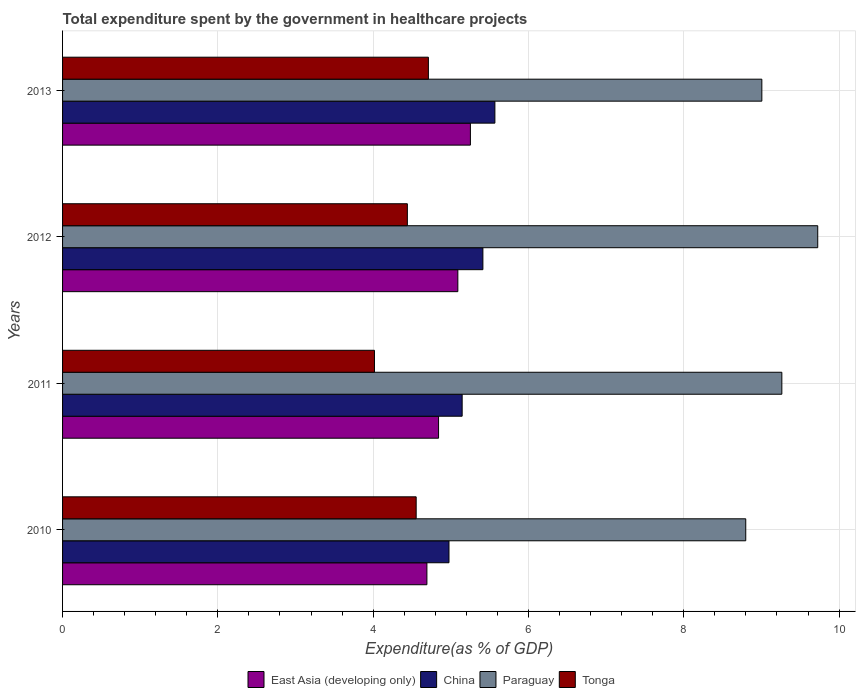How many groups of bars are there?
Offer a very short reply. 4. How many bars are there on the 4th tick from the bottom?
Make the answer very short. 4. What is the label of the 4th group of bars from the top?
Provide a succinct answer. 2010. In how many cases, is the number of bars for a given year not equal to the number of legend labels?
Provide a short and direct response. 0. What is the total expenditure spent by the government in healthcare projects in East Asia (developing only) in 2013?
Your answer should be very brief. 5.25. Across all years, what is the maximum total expenditure spent by the government in healthcare projects in Paraguay?
Your response must be concise. 9.73. Across all years, what is the minimum total expenditure spent by the government in healthcare projects in East Asia (developing only)?
Your answer should be compact. 4.69. In which year was the total expenditure spent by the government in healthcare projects in East Asia (developing only) minimum?
Offer a terse response. 2010. What is the total total expenditure spent by the government in healthcare projects in China in the graph?
Give a very brief answer. 21.1. What is the difference between the total expenditure spent by the government in healthcare projects in East Asia (developing only) in 2010 and that in 2012?
Your response must be concise. -0.4. What is the difference between the total expenditure spent by the government in healthcare projects in East Asia (developing only) in 2010 and the total expenditure spent by the government in healthcare projects in China in 2013?
Provide a succinct answer. -0.88. What is the average total expenditure spent by the government in healthcare projects in China per year?
Keep it short and to the point. 5.28. In the year 2012, what is the difference between the total expenditure spent by the government in healthcare projects in Tonga and total expenditure spent by the government in healthcare projects in East Asia (developing only)?
Provide a short and direct response. -0.65. What is the ratio of the total expenditure spent by the government in healthcare projects in Tonga in 2010 to that in 2013?
Offer a very short reply. 0.97. What is the difference between the highest and the second highest total expenditure spent by the government in healthcare projects in Paraguay?
Keep it short and to the point. 0.46. What is the difference between the highest and the lowest total expenditure spent by the government in healthcare projects in Tonga?
Give a very brief answer. 0.69. In how many years, is the total expenditure spent by the government in healthcare projects in China greater than the average total expenditure spent by the government in healthcare projects in China taken over all years?
Your answer should be compact. 2. Is the sum of the total expenditure spent by the government in healthcare projects in Tonga in 2011 and 2012 greater than the maximum total expenditure spent by the government in healthcare projects in China across all years?
Provide a succinct answer. Yes. Is it the case that in every year, the sum of the total expenditure spent by the government in healthcare projects in China and total expenditure spent by the government in healthcare projects in Paraguay is greater than the sum of total expenditure spent by the government in healthcare projects in Tonga and total expenditure spent by the government in healthcare projects in East Asia (developing only)?
Your answer should be compact. Yes. What does the 4th bar from the bottom in 2012 represents?
Give a very brief answer. Tonga. How many bars are there?
Provide a short and direct response. 16. Does the graph contain any zero values?
Your answer should be very brief. No. How many legend labels are there?
Offer a terse response. 4. What is the title of the graph?
Ensure brevity in your answer.  Total expenditure spent by the government in healthcare projects. What is the label or title of the X-axis?
Provide a succinct answer. Expenditure(as % of GDP). What is the Expenditure(as % of GDP) of East Asia (developing only) in 2010?
Your response must be concise. 4.69. What is the Expenditure(as % of GDP) in China in 2010?
Offer a terse response. 4.98. What is the Expenditure(as % of GDP) in Paraguay in 2010?
Your answer should be compact. 8.8. What is the Expenditure(as % of GDP) in Tonga in 2010?
Keep it short and to the point. 4.55. What is the Expenditure(as % of GDP) of East Asia (developing only) in 2011?
Offer a very short reply. 4.84. What is the Expenditure(as % of GDP) of China in 2011?
Your answer should be very brief. 5.15. What is the Expenditure(as % of GDP) of Paraguay in 2011?
Keep it short and to the point. 9.26. What is the Expenditure(as % of GDP) in Tonga in 2011?
Offer a very short reply. 4.02. What is the Expenditure(as % of GDP) of East Asia (developing only) in 2012?
Your response must be concise. 5.09. What is the Expenditure(as % of GDP) in China in 2012?
Provide a succinct answer. 5.41. What is the Expenditure(as % of GDP) in Paraguay in 2012?
Give a very brief answer. 9.73. What is the Expenditure(as % of GDP) of Tonga in 2012?
Give a very brief answer. 4.44. What is the Expenditure(as % of GDP) in East Asia (developing only) in 2013?
Your answer should be compact. 5.25. What is the Expenditure(as % of GDP) in China in 2013?
Your answer should be very brief. 5.57. What is the Expenditure(as % of GDP) of Paraguay in 2013?
Offer a very short reply. 9.01. What is the Expenditure(as % of GDP) of Tonga in 2013?
Offer a very short reply. 4.71. Across all years, what is the maximum Expenditure(as % of GDP) in East Asia (developing only)?
Provide a succinct answer. 5.25. Across all years, what is the maximum Expenditure(as % of GDP) in China?
Offer a very short reply. 5.57. Across all years, what is the maximum Expenditure(as % of GDP) in Paraguay?
Offer a terse response. 9.73. Across all years, what is the maximum Expenditure(as % of GDP) in Tonga?
Provide a short and direct response. 4.71. Across all years, what is the minimum Expenditure(as % of GDP) in East Asia (developing only)?
Provide a succinct answer. 4.69. Across all years, what is the minimum Expenditure(as % of GDP) of China?
Offer a very short reply. 4.98. Across all years, what is the minimum Expenditure(as % of GDP) of Paraguay?
Offer a very short reply. 8.8. Across all years, what is the minimum Expenditure(as % of GDP) of Tonga?
Keep it short and to the point. 4.02. What is the total Expenditure(as % of GDP) in East Asia (developing only) in the graph?
Provide a succinct answer. 19.88. What is the total Expenditure(as % of GDP) of China in the graph?
Keep it short and to the point. 21.1. What is the total Expenditure(as % of GDP) of Paraguay in the graph?
Give a very brief answer. 36.79. What is the total Expenditure(as % of GDP) in Tonga in the graph?
Make the answer very short. 17.72. What is the difference between the Expenditure(as % of GDP) in East Asia (developing only) in 2010 and that in 2011?
Your answer should be compact. -0.15. What is the difference between the Expenditure(as % of GDP) in China in 2010 and that in 2011?
Offer a terse response. -0.17. What is the difference between the Expenditure(as % of GDP) in Paraguay in 2010 and that in 2011?
Your answer should be very brief. -0.46. What is the difference between the Expenditure(as % of GDP) in Tonga in 2010 and that in 2011?
Provide a succinct answer. 0.54. What is the difference between the Expenditure(as % of GDP) in East Asia (developing only) in 2010 and that in 2012?
Ensure brevity in your answer.  -0.4. What is the difference between the Expenditure(as % of GDP) in China in 2010 and that in 2012?
Offer a terse response. -0.44. What is the difference between the Expenditure(as % of GDP) in Paraguay in 2010 and that in 2012?
Your response must be concise. -0.93. What is the difference between the Expenditure(as % of GDP) of Tonga in 2010 and that in 2012?
Keep it short and to the point. 0.11. What is the difference between the Expenditure(as % of GDP) of East Asia (developing only) in 2010 and that in 2013?
Provide a succinct answer. -0.56. What is the difference between the Expenditure(as % of GDP) of China in 2010 and that in 2013?
Make the answer very short. -0.59. What is the difference between the Expenditure(as % of GDP) of Paraguay in 2010 and that in 2013?
Provide a succinct answer. -0.21. What is the difference between the Expenditure(as % of GDP) in Tonga in 2010 and that in 2013?
Offer a terse response. -0.16. What is the difference between the Expenditure(as % of GDP) in East Asia (developing only) in 2011 and that in 2012?
Offer a terse response. -0.25. What is the difference between the Expenditure(as % of GDP) in China in 2011 and that in 2012?
Provide a short and direct response. -0.27. What is the difference between the Expenditure(as % of GDP) of Paraguay in 2011 and that in 2012?
Keep it short and to the point. -0.46. What is the difference between the Expenditure(as % of GDP) of Tonga in 2011 and that in 2012?
Provide a short and direct response. -0.42. What is the difference between the Expenditure(as % of GDP) in East Asia (developing only) in 2011 and that in 2013?
Ensure brevity in your answer.  -0.41. What is the difference between the Expenditure(as % of GDP) of China in 2011 and that in 2013?
Make the answer very short. -0.42. What is the difference between the Expenditure(as % of GDP) in Paraguay in 2011 and that in 2013?
Make the answer very short. 0.26. What is the difference between the Expenditure(as % of GDP) of Tonga in 2011 and that in 2013?
Make the answer very short. -0.69. What is the difference between the Expenditure(as % of GDP) in East Asia (developing only) in 2012 and that in 2013?
Your response must be concise. -0.16. What is the difference between the Expenditure(as % of GDP) of China in 2012 and that in 2013?
Keep it short and to the point. -0.15. What is the difference between the Expenditure(as % of GDP) in Paraguay in 2012 and that in 2013?
Provide a succinct answer. 0.72. What is the difference between the Expenditure(as % of GDP) of Tonga in 2012 and that in 2013?
Provide a succinct answer. -0.27. What is the difference between the Expenditure(as % of GDP) in East Asia (developing only) in 2010 and the Expenditure(as % of GDP) in China in 2011?
Give a very brief answer. -0.45. What is the difference between the Expenditure(as % of GDP) of East Asia (developing only) in 2010 and the Expenditure(as % of GDP) of Paraguay in 2011?
Your response must be concise. -4.57. What is the difference between the Expenditure(as % of GDP) in East Asia (developing only) in 2010 and the Expenditure(as % of GDP) in Tonga in 2011?
Your answer should be compact. 0.68. What is the difference between the Expenditure(as % of GDP) in China in 2010 and the Expenditure(as % of GDP) in Paraguay in 2011?
Give a very brief answer. -4.29. What is the difference between the Expenditure(as % of GDP) of China in 2010 and the Expenditure(as % of GDP) of Tonga in 2011?
Offer a terse response. 0.96. What is the difference between the Expenditure(as % of GDP) in Paraguay in 2010 and the Expenditure(as % of GDP) in Tonga in 2011?
Provide a short and direct response. 4.78. What is the difference between the Expenditure(as % of GDP) of East Asia (developing only) in 2010 and the Expenditure(as % of GDP) of China in 2012?
Provide a short and direct response. -0.72. What is the difference between the Expenditure(as % of GDP) in East Asia (developing only) in 2010 and the Expenditure(as % of GDP) in Paraguay in 2012?
Keep it short and to the point. -5.03. What is the difference between the Expenditure(as % of GDP) in East Asia (developing only) in 2010 and the Expenditure(as % of GDP) in Tonga in 2012?
Give a very brief answer. 0.25. What is the difference between the Expenditure(as % of GDP) in China in 2010 and the Expenditure(as % of GDP) in Paraguay in 2012?
Your answer should be very brief. -4.75. What is the difference between the Expenditure(as % of GDP) of China in 2010 and the Expenditure(as % of GDP) of Tonga in 2012?
Make the answer very short. 0.54. What is the difference between the Expenditure(as % of GDP) of Paraguay in 2010 and the Expenditure(as % of GDP) of Tonga in 2012?
Keep it short and to the point. 4.36. What is the difference between the Expenditure(as % of GDP) of East Asia (developing only) in 2010 and the Expenditure(as % of GDP) of China in 2013?
Provide a succinct answer. -0.88. What is the difference between the Expenditure(as % of GDP) of East Asia (developing only) in 2010 and the Expenditure(as % of GDP) of Paraguay in 2013?
Provide a succinct answer. -4.31. What is the difference between the Expenditure(as % of GDP) of East Asia (developing only) in 2010 and the Expenditure(as % of GDP) of Tonga in 2013?
Keep it short and to the point. -0.02. What is the difference between the Expenditure(as % of GDP) in China in 2010 and the Expenditure(as % of GDP) in Paraguay in 2013?
Your response must be concise. -4.03. What is the difference between the Expenditure(as % of GDP) in China in 2010 and the Expenditure(as % of GDP) in Tonga in 2013?
Provide a short and direct response. 0.27. What is the difference between the Expenditure(as % of GDP) in Paraguay in 2010 and the Expenditure(as % of GDP) in Tonga in 2013?
Provide a succinct answer. 4.09. What is the difference between the Expenditure(as % of GDP) in East Asia (developing only) in 2011 and the Expenditure(as % of GDP) in China in 2012?
Your response must be concise. -0.57. What is the difference between the Expenditure(as % of GDP) in East Asia (developing only) in 2011 and the Expenditure(as % of GDP) in Paraguay in 2012?
Your response must be concise. -4.88. What is the difference between the Expenditure(as % of GDP) in East Asia (developing only) in 2011 and the Expenditure(as % of GDP) in Tonga in 2012?
Keep it short and to the point. 0.4. What is the difference between the Expenditure(as % of GDP) of China in 2011 and the Expenditure(as % of GDP) of Paraguay in 2012?
Ensure brevity in your answer.  -4.58. What is the difference between the Expenditure(as % of GDP) in China in 2011 and the Expenditure(as % of GDP) in Tonga in 2012?
Offer a terse response. 0.71. What is the difference between the Expenditure(as % of GDP) in Paraguay in 2011 and the Expenditure(as % of GDP) in Tonga in 2012?
Offer a terse response. 4.82. What is the difference between the Expenditure(as % of GDP) of East Asia (developing only) in 2011 and the Expenditure(as % of GDP) of China in 2013?
Ensure brevity in your answer.  -0.73. What is the difference between the Expenditure(as % of GDP) in East Asia (developing only) in 2011 and the Expenditure(as % of GDP) in Paraguay in 2013?
Give a very brief answer. -4.16. What is the difference between the Expenditure(as % of GDP) of East Asia (developing only) in 2011 and the Expenditure(as % of GDP) of Tonga in 2013?
Your response must be concise. 0.13. What is the difference between the Expenditure(as % of GDP) of China in 2011 and the Expenditure(as % of GDP) of Paraguay in 2013?
Offer a terse response. -3.86. What is the difference between the Expenditure(as % of GDP) of China in 2011 and the Expenditure(as % of GDP) of Tonga in 2013?
Keep it short and to the point. 0.43. What is the difference between the Expenditure(as % of GDP) in Paraguay in 2011 and the Expenditure(as % of GDP) in Tonga in 2013?
Offer a very short reply. 4.55. What is the difference between the Expenditure(as % of GDP) of East Asia (developing only) in 2012 and the Expenditure(as % of GDP) of China in 2013?
Your answer should be very brief. -0.48. What is the difference between the Expenditure(as % of GDP) in East Asia (developing only) in 2012 and the Expenditure(as % of GDP) in Paraguay in 2013?
Provide a succinct answer. -3.91. What is the difference between the Expenditure(as % of GDP) of East Asia (developing only) in 2012 and the Expenditure(as % of GDP) of Tonga in 2013?
Keep it short and to the point. 0.38. What is the difference between the Expenditure(as % of GDP) of China in 2012 and the Expenditure(as % of GDP) of Paraguay in 2013?
Make the answer very short. -3.59. What is the difference between the Expenditure(as % of GDP) in China in 2012 and the Expenditure(as % of GDP) in Tonga in 2013?
Your answer should be compact. 0.7. What is the difference between the Expenditure(as % of GDP) of Paraguay in 2012 and the Expenditure(as % of GDP) of Tonga in 2013?
Your response must be concise. 5.01. What is the average Expenditure(as % of GDP) of East Asia (developing only) per year?
Offer a very short reply. 4.97. What is the average Expenditure(as % of GDP) in China per year?
Provide a succinct answer. 5.28. What is the average Expenditure(as % of GDP) in Paraguay per year?
Your response must be concise. 9.2. What is the average Expenditure(as % of GDP) of Tonga per year?
Your response must be concise. 4.43. In the year 2010, what is the difference between the Expenditure(as % of GDP) in East Asia (developing only) and Expenditure(as % of GDP) in China?
Your answer should be compact. -0.28. In the year 2010, what is the difference between the Expenditure(as % of GDP) in East Asia (developing only) and Expenditure(as % of GDP) in Paraguay?
Provide a succinct answer. -4.11. In the year 2010, what is the difference between the Expenditure(as % of GDP) of East Asia (developing only) and Expenditure(as % of GDP) of Tonga?
Offer a terse response. 0.14. In the year 2010, what is the difference between the Expenditure(as % of GDP) in China and Expenditure(as % of GDP) in Paraguay?
Provide a succinct answer. -3.82. In the year 2010, what is the difference between the Expenditure(as % of GDP) in China and Expenditure(as % of GDP) in Tonga?
Give a very brief answer. 0.42. In the year 2010, what is the difference between the Expenditure(as % of GDP) in Paraguay and Expenditure(as % of GDP) in Tonga?
Offer a very short reply. 4.24. In the year 2011, what is the difference between the Expenditure(as % of GDP) in East Asia (developing only) and Expenditure(as % of GDP) in China?
Give a very brief answer. -0.3. In the year 2011, what is the difference between the Expenditure(as % of GDP) of East Asia (developing only) and Expenditure(as % of GDP) of Paraguay?
Offer a very short reply. -4.42. In the year 2011, what is the difference between the Expenditure(as % of GDP) of East Asia (developing only) and Expenditure(as % of GDP) of Tonga?
Your answer should be compact. 0.83. In the year 2011, what is the difference between the Expenditure(as % of GDP) in China and Expenditure(as % of GDP) in Paraguay?
Offer a terse response. -4.12. In the year 2011, what is the difference between the Expenditure(as % of GDP) in China and Expenditure(as % of GDP) in Tonga?
Your answer should be very brief. 1.13. In the year 2011, what is the difference between the Expenditure(as % of GDP) of Paraguay and Expenditure(as % of GDP) of Tonga?
Keep it short and to the point. 5.25. In the year 2012, what is the difference between the Expenditure(as % of GDP) of East Asia (developing only) and Expenditure(as % of GDP) of China?
Keep it short and to the point. -0.32. In the year 2012, what is the difference between the Expenditure(as % of GDP) in East Asia (developing only) and Expenditure(as % of GDP) in Paraguay?
Ensure brevity in your answer.  -4.63. In the year 2012, what is the difference between the Expenditure(as % of GDP) in East Asia (developing only) and Expenditure(as % of GDP) in Tonga?
Offer a terse response. 0.65. In the year 2012, what is the difference between the Expenditure(as % of GDP) of China and Expenditure(as % of GDP) of Paraguay?
Give a very brief answer. -4.31. In the year 2012, what is the difference between the Expenditure(as % of GDP) in China and Expenditure(as % of GDP) in Tonga?
Your answer should be compact. 0.97. In the year 2012, what is the difference between the Expenditure(as % of GDP) of Paraguay and Expenditure(as % of GDP) of Tonga?
Offer a terse response. 5.28. In the year 2013, what is the difference between the Expenditure(as % of GDP) of East Asia (developing only) and Expenditure(as % of GDP) of China?
Give a very brief answer. -0.32. In the year 2013, what is the difference between the Expenditure(as % of GDP) in East Asia (developing only) and Expenditure(as % of GDP) in Paraguay?
Provide a succinct answer. -3.75. In the year 2013, what is the difference between the Expenditure(as % of GDP) in East Asia (developing only) and Expenditure(as % of GDP) in Tonga?
Offer a terse response. 0.54. In the year 2013, what is the difference between the Expenditure(as % of GDP) in China and Expenditure(as % of GDP) in Paraguay?
Your response must be concise. -3.44. In the year 2013, what is the difference between the Expenditure(as % of GDP) of China and Expenditure(as % of GDP) of Tonga?
Provide a succinct answer. 0.86. In the year 2013, what is the difference between the Expenditure(as % of GDP) in Paraguay and Expenditure(as % of GDP) in Tonga?
Make the answer very short. 4.29. What is the ratio of the Expenditure(as % of GDP) of China in 2010 to that in 2011?
Give a very brief answer. 0.97. What is the ratio of the Expenditure(as % of GDP) of Paraguay in 2010 to that in 2011?
Provide a short and direct response. 0.95. What is the ratio of the Expenditure(as % of GDP) in Tonga in 2010 to that in 2011?
Provide a short and direct response. 1.13. What is the ratio of the Expenditure(as % of GDP) of East Asia (developing only) in 2010 to that in 2012?
Keep it short and to the point. 0.92. What is the ratio of the Expenditure(as % of GDP) in China in 2010 to that in 2012?
Ensure brevity in your answer.  0.92. What is the ratio of the Expenditure(as % of GDP) of Paraguay in 2010 to that in 2012?
Provide a short and direct response. 0.9. What is the ratio of the Expenditure(as % of GDP) of Tonga in 2010 to that in 2012?
Make the answer very short. 1.03. What is the ratio of the Expenditure(as % of GDP) of East Asia (developing only) in 2010 to that in 2013?
Your answer should be very brief. 0.89. What is the ratio of the Expenditure(as % of GDP) of China in 2010 to that in 2013?
Your answer should be compact. 0.89. What is the ratio of the Expenditure(as % of GDP) of Paraguay in 2010 to that in 2013?
Ensure brevity in your answer.  0.98. What is the ratio of the Expenditure(as % of GDP) of Tonga in 2010 to that in 2013?
Make the answer very short. 0.97. What is the ratio of the Expenditure(as % of GDP) in East Asia (developing only) in 2011 to that in 2012?
Offer a very short reply. 0.95. What is the ratio of the Expenditure(as % of GDP) in China in 2011 to that in 2012?
Your answer should be very brief. 0.95. What is the ratio of the Expenditure(as % of GDP) in Paraguay in 2011 to that in 2012?
Provide a succinct answer. 0.95. What is the ratio of the Expenditure(as % of GDP) in Tonga in 2011 to that in 2012?
Offer a terse response. 0.9. What is the ratio of the Expenditure(as % of GDP) in East Asia (developing only) in 2011 to that in 2013?
Provide a short and direct response. 0.92. What is the ratio of the Expenditure(as % of GDP) of China in 2011 to that in 2013?
Give a very brief answer. 0.92. What is the ratio of the Expenditure(as % of GDP) of Paraguay in 2011 to that in 2013?
Offer a terse response. 1.03. What is the ratio of the Expenditure(as % of GDP) in Tonga in 2011 to that in 2013?
Your answer should be very brief. 0.85. What is the ratio of the Expenditure(as % of GDP) of East Asia (developing only) in 2012 to that in 2013?
Your answer should be very brief. 0.97. What is the ratio of the Expenditure(as % of GDP) of China in 2012 to that in 2013?
Ensure brevity in your answer.  0.97. What is the ratio of the Expenditure(as % of GDP) of Paraguay in 2012 to that in 2013?
Your response must be concise. 1.08. What is the ratio of the Expenditure(as % of GDP) of Tonga in 2012 to that in 2013?
Your answer should be very brief. 0.94. What is the difference between the highest and the second highest Expenditure(as % of GDP) in East Asia (developing only)?
Ensure brevity in your answer.  0.16. What is the difference between the highest and the second highest Expenditure(as % of GDP) of China?
Your answer should be compact. 0.15. What is the difference between the highest and the second highest Expenditure(as % of GDP) of Paraguay?
Keep it short and to the point. 0.46. What is the difference between the highest and the second highest Expenditure(as % of GDP) in Tonga?
Offer a very short reply. 0.16. What is the difference between the highest and the lowest Expenditure(as % of GDP) in East Asia (developing only)?
Give a very brief answer. 0.56. What is the difference between the highest and the lowest Expenditure(as % of GDP) of China?
Your answer should be very brief. 0.59. What is the difference between the highest and the lowest Expenditure(as % of GDP) of Paraguay?
Keep it short and to the point. 0.93. What is the difference between the highest and the lowest Expenditure(as % of GDP) of Tonga?
Provide a short and direct response. 0.69. 